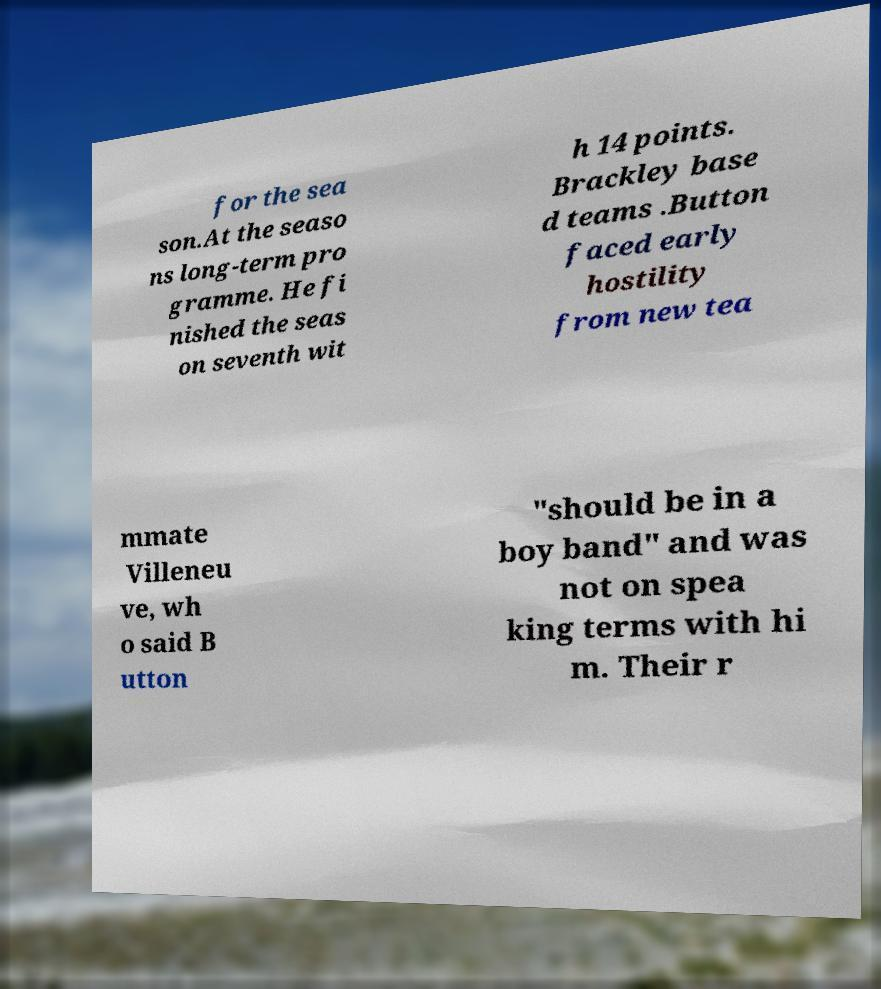Could you extract and type out the text from this image? for the sea son.At the seaso ns long-term pro gramme. He fi nished the seas on seventh wit h 14 points. Brackley base d teams .Button faced early hostility from new tea mmate Villeneu ve, wh o said B utton "should be in a boy band" and was not on spea king terms with hi m. Their r 